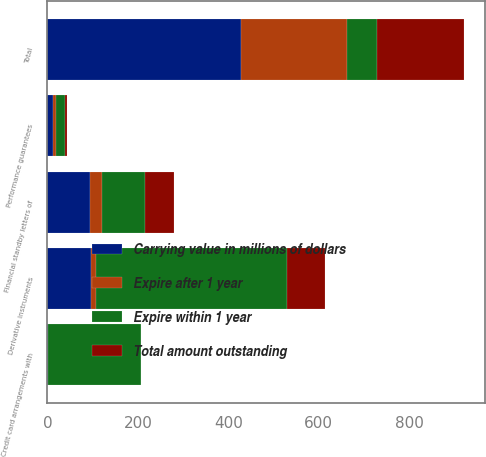<chart> <loc_0><loc_0><loc_500><loc_500><stacked_bar_chart><ecel><fcel>Financial standby letters of<fcel>Performance guarantees<fcel>Derivative instruments<fcel>Credit card arrangements with<fcel>Total<nl><fcel>Expire after 1 year<fcel>27.9<fcel>7.2<fcel>11<fcel>0.3<fcel>235.6<nl><fcel>Total amount outstanding<fcel>65.9<fcel>4.1<fcel>84.9<fcel>1.1<fcel>192.2<nl><fcel>Carrying value in millions of dollars<fcel>93.8<fcel>11.3<fcel>95.9<fcel>1.4<fcel>427.8<nl><fcel>Expire within 1 year<fcel>93<fcel>20<fcel>423<fcel>205<fcel>65.9<nl></chart> 